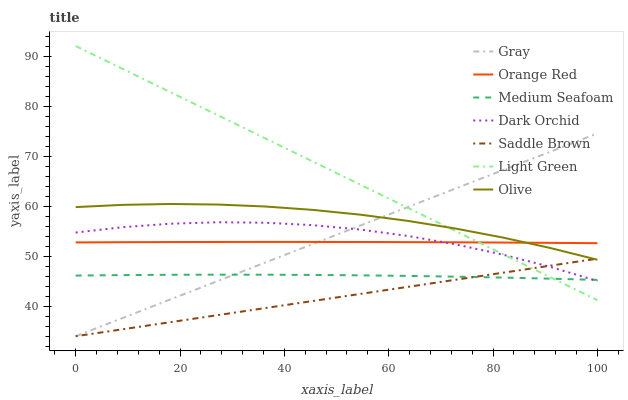Does Saddle Brown have the minimum area under the curve?
Answer yes or no. Yes. Does Light Green have the maximum area under the curve?
Answer yes or no. Yes. Does Dark Orchid have the minimum area under the curve?
Answer yes or no. No. Does Dark Orchid have the maximum area under the curve?
Answer yes or no. No. Is Saddle Brown the smoothest?
Answer yes or no. Yes. Is Dark Orchid the roughest?
Answer yes or no. Yes. Is Orange Red the smoothest?
Answer yes or no. No. Is Orange Red the roughest?
Answer yes or no. No. Does Gray have the lowest value?
Answer yes or no. Yes. Does Dark Orchid have the lowest value?
Answer yes or no. No. Does Light Green have the highest value?
Answer yes or no. Yes. Does Dark Orchid have the highest value?
Answer yes or no. No. Is Dark Orchid less than Olive?
Answer yes or no. Yes. Is Orange Red greater than Medium Seafoam?
Answer yes or no. Yes. Does Light Green intersect Dark Orchid?
Answer yes or no. Yes. Is Light Green less than Dark Orchid?
Answer yes or no. No. Is Light Green greater than Dark Orchid?
Answer yes or no. No. Does Dark Orchid intersect Olive?
Answer yes or no. No. 